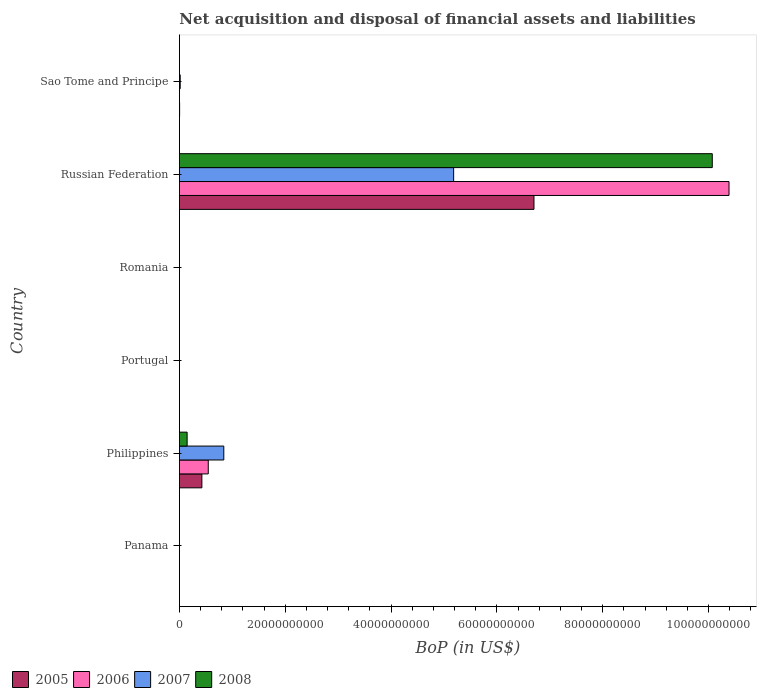How many different coloured bars are there?
Make the answer very short. 4. How many bars are there on the 1st tick from the top?
Keep it short and to the point. 2. How many bars are there on the 3rd tick from the bottom?
Your answer should be compact. 0. What is the label of the 3rd group of bars from the top?
Give a very brief answer. Romania. In how many cases, is the number of bars for a given country not equal to the number of legend labels?
Your answer should be very brief. 4. What is the Balance of Payments in 2006 in Sao Tome and Principe?
Your answer should be very brief. 0. Across all countries, what is the maximum Balance of Payments in 2006?
Offer a very short reply. 1.04e+11. Across all countries, what is the minimum Balance of Payments in 2007?
Give a very brief answer. 0. In which country was the Balance of Payments in 2006 maximum?
Your answer should be compact. Russian Federation. What is the total Balance of Payments in 2007 in the graph?
Make the answer very short. 6.04e+1. What is the difference between the Balance of Payments in 2005 in Philippines and that in Russian Federation?
Your answer should be compact. -6.28e+1. What is the difference between the Balance of Payments in 2007 in Russian Federation and the Balance of Payments in 2008 in Romania?
Your response must be concise. 5.18e+1. What is the average Balance of Payments in 2005 per country?
Ensure brevity in your answer.  1.19e+1. What is the difference between the Balance of Payments in 2008 and Balance of Payments in 2005 in Russian Federation?
Offer a very short reply. 3.37e+1. In how many countries, is the Balance of Payments in 2006 greater than 28000000000 US$?
Provide a succinct answer. 1. What is the difference between the highest and the second highest Balance of Payments in 2005?
Provide a succinct answer. 6.28e+1. What is the difference between the highest and the lowest Balance of Payments in 2007?
Your response must be concise. 5.18e+1. In how many countries, is the Balance of Payments in 2005 greater than the average Balance of Payments in 2005 taken over all countries?
Keep it short and to the point. 1. Is the sum of the Balance of Payments in 2005 in Philippines and Sao Tome and Principe greater than the maximum Balance of Payments in 2006 across all countries?
Ensure brevity in your answer.  No. Is it the case that in every country, the sum of the Balance of Payments in 2007 and Balance of Payments in 2008 is greater than the Balance of Payments in 2006?
Offer a very short reply. No. How many bars are there?
Keep it short and to the point. 10. Are all the bars in the graph horizontal?
Give a very brief answer. Yes. How many countries are there in the graph?
Provide a succinct answer. 6. What is the difference between two consecutive major ticks on the X-axis?
Offer a terse response. 2.00e+1. Does the graph contain any zero values?
Ensure brevity in your answer.  Yes. Where does the legend appear in the graph?
Your answer should be compact. Bottom left. What is the title of the graph?
Provide a succinct answer. Net acquisition and disposal of financial assets and liabilities. What is the label or title of the X-axis?
Ensure brevity in your answer.  BoP (in US$). What is the BoP (in US$) in 2005 in Philippines?
Provide a short and direct response. 4.24e+09. What is the BoP (in US$) of 2006 in Philippines?
Provide a short and direct response. 5.45e+09. What is the BoP (in US$) in 2007 in Philippines?
Provide a short and direct response. 8.39e+09. What is the BoP (in US$) of 2008 in Philippines?
Your response must be concise. 1.46e+09. What is the BoP (in US$) in 2005 in Portugal?
Ensure brevity in your answer.  0. What is the BoP (in US$) of 2007 in Portugal?
Provide a short and direct response. 0. What is the BoP (in US$) in 2006 in Romania?
Provide a succinct answer. 0. What is the BoP (in US$) in 2008 in Romania?
Give a very brief answer. 0. What is the BoP (in US$) of 2005 in Russian Federation?
Your response must be concise. 6.70e+1. What is the BoP (in US$) of 2006 in Russian Federation?
Give a very brief answer. 1.04e+11. What is the BoP (in US$) of 2007 in Russian Federation?
Ensure brevity in your answer.  5.18e+1. What is the BoP (in US$) of 2008 in Russian Federation?
Provide a succinct answer. 1.01e+11. What is the BoP (in US$) in 2005 in Sao Tome and Principe?
Give a very brief answer. 3.62e+07. What is the BoP (in US$) of 2007 in Sao Tome and Principe?
Give a very brief answer. 1.50e+08. What is the BoP (in US$) of 2008 in Sao Tome and Principe?
Your answer should be very brief. 0. Across all countries, what is the maximum BoP (in US$) in 2005?
Give a very brief answer. 6.70e+1. Across all countries, what is the maximum BoP (in US$) of 2006?
Offer a terse response. 1.04e+11. Across all countries, what is the maximum BoP (in US$) of 2007?
Provide a short and direct response. 5.18e+1. Across all countries, what is the maximum BoP (in US$) in 2008?
Offer a very short reply. 1.01e+11. Across all countries, what is the minimum BoP (in US$) in 2005?
Provide a succinct answer. 0. Across all countries, what is the minimum BoP (in US$) of 2008?
Provide a succinct answer. 0. What is the total BoP (in US$) of 2005 in the graph?
Offer a terse response. 7.13e+1. What is the total BoP (in US$) of 2006 in the graph?
Make the answer very short. 1.09e+11. What is the total BoP (in US$) of 2007 in the graph?
Keep it short and to the point. 6.04e+1. What is the total BoP (in US$) in 2008 in the graph?
Your response must be concise. 1.02e+11. What is the difference between the BoP (in US$) in 2005 in Philippines and that in Russian Federation?
Provide a short and direct response. -6.28e+1. What is the difference between the BoP (in US$) of 2006 in Philippines and that in Russian Federation?
Ensure brevity in your answer.  -9.84e+1. What is the difference between the BoP (in US$) in 2007 in Philippines and that in Russian Federation?
Give a very brief answer. -4.34e+1. What is the difference between the BoP (in US$) of 2008 in Philippines and that in Russian Federation?
Give a very brief answer. -9.92e+1. What is the difference between the BoP (in US$) of 2005 in Philippines and that in Sao Tome and Principe?
Provide a succinct answer. 4.21e+09. What is the difference between the BoP (in US$) in 2007 in Philippines and that in Sao Tome and Principe?
Your answer should be compact. 8.24e+09. What is the difference between the BoP (in US$) of 2005 in Russian Federation and that in Sao Tome and Principe?
Keep it short and to the point. 6.70e+1. What is the difference between the BoP (in US$) in 2007 in Russian Federation and that in Sao Tome and Principe?
Provide a succinct answer. 5.17e+1. What is the difference between the BoP (in US$) in 2005 in Philippines and the BoP (in US$) in 2006 in Russian Federation?
Make the answer very short. -9.96e+1. What is the difference between the BoP (in US$) of 2005 in Philippines and the BoP (in US$) of 2007 in Russian Federation?
Make the answer very short. -4.76e+1. What is the difference between the BoP (in US$) of 2005 in Philippines and the BoP (in US$) of 2008 in Russian Federation?
Keep it short and to the point. -9.64e+1. What is the difference between the BoP (in US$) of 2006 in Philippines and the BoP (in US$) of 2007 in Russian Federation?
Provide a short and direct response. -4.64e+1. What is the difference between the BoP (in US$) in 2006 in Philippines and the BoP (in US$) in 2008 in Russian Federation?
Your response must be concise. -9.52e+1. What is the difference between the BoP (in US$) of 2007 in Philippines and the BoP (in US$) of 2008 in Russian Federation?
Keep it short and to the point. -9.23e+1. What is the difference between the BoP (in US$) in 2005 in Philippines and the BoP (in US$) in 2007 in Sao Tome and Principe?
Offer a very short reply. 4.09e+09. What is the difference between the BoP (in US$) of 2006 in Philippines and the BoP (in US$) of 2007 in Sao Tome and Principe?
Your answer should be very brief. 5.30e+09. What is the difference between the BoP (in US$) of 2005 in Russian Federation and the BoP (in US$) of 2007 in Sao Tome and Principe?
Offer a very short reply. 6.68e+1. What is the difference between the BoP (in US$) of 2006 in Russian Federation and the BoP (in US$) of 2007 in Sao Tome and Principe?
Provide a short and direct response. 1.04e+11. What is the average BoP (in US$) in 2005 per country?
Make the answer very short. 1.19e+1. What is the average BoP (in US$) in 2006 per country?
Give a very brief answer. 1.82e+1. What is the average BoP (in US$) of 2007 per country?
Provide a short and direct response. 1.01e+1. What is the average BoP (in US$) in 2008 per country?
Offer a very short reply. 1.70e+1. What is the difference between the BoP (in US$) of 2005 and BoP (in US$) of 2006 in Philippines?
Your answer should be compact. -1.21e+09. What is the difference between the BoP (in US$) in 2005 and BoP (in US$) in 2007 in Philippines?
Offer a very short reply. -4.14e+09. What is the difference between the BoP (in US$) of 2005 and BoP (in US$) of 2008 in Philippines?
Your answer should be very brief. 2.79e+09. What is the difference between the BoP (in US$) of 2006 and BoP (in US$) of 2007 in Philippines?
Keep it short and to the point. -2.93e+09. What is the difference between the BoP (in US$) of 2006 and BoP (in US$) of 2008 in Philippines?
Offer a terse response. 3.99e+09. What is the difference between the BoP (in US$) of 2007 and BoP (in US$) of 2008 in Philippines?
Your response must be concise. 6.93e+09. What is the difference between the BoP (in US$) in 2005 and BoP (in US$) in 2006 in Russian Federation?
Give a very brief answer. -3.69e+1. What is the difference between the BoP (in US$) in 2005 and BoP (in US$) in 2007 in Russian Federation?
Give a very brief answer. 1.52e+1. What is the difference between the BoP (in US$) of 2005 and BoP (in US$) of 2008 in Russian Federation?
Provide a short and direct response. -3.37e+1. What is the difference between the BoP (in US$) of 2006 and BoP (in US$) of 2007 in Russian Federation?
Provide a succinct answer. 5.20e+1. What is the difference between the BoP (in US$) in 2006 and BoP (in US$) in 2008 in Russian Federation?
Ensure brevity in your answer.  3.16e+09. What is the difference between the BoP (in US$) in 2007 and BoP (in US$) in 2008 in Russian Federation?
Your response must be concise. -4.89e+1. What is the difference between the BoP (in US$) in 2005 and BoP (in US$) in 2007 in Sao Tome and Principe?
Offer a terse response. -1.14e+08. What is the ratio of the BoP (in US$) in 2005 in Philippines to that in Russian Federation?
Give a very brief answer. 0.06. What is the ratio of the BoP (in US$) in 2006 in Philippines to that in Russian Federation?
Your answer should be very brief. 0.05. What is the ratio of the BoP (in US$) of 2007 in Philippines to that in Russian Federation?
Ensure brevity in your answer.  0.16. What is the ratio of the BoP (in US$) in 2008 in Philippines to that in Russian Federation?
Your answer should be very brief. 0.01. What is the ratio of the BoP (in US$) in 2005 in Philippines to that in Sao Tome and Principe?
Give a very brief answer. 117.32. What is the ratio of the BoP (in US$) in 2007 in Philippines to that in Sao Tome and Principe?
Provide a short and direct response. 55.73. What is the ratio of the BoP (in US$) of 2005 in Russian Federation to that in Sao Tome and Principe?
Keep it short and to the point. 1852.28. What is the ratio of the BoP (in US$) in 2007 in Russian Federation to that in Sao Tome and Principe?
Make the answer very short. 344.37. What is the difference between the highest and the second highest BoP (in US$) of 2005?
Offer a terse response. 6.28e+1. What is the difference between the highest and the second highest BoP (in US$) of 2007?
Give a very brief answer. 4.34e+1. What is the difference between the highest and the lowest BoP (in US$) in 2005?
Your response must be concise. 6.70e+1. What is the difference between the highest and the lowest BoP (in US$) of 2006?
Offer a very short reply. 1.04e+11. What is the difference between the highest and the lowest BoP (in US$) in 2007?
Ensure brevity in your answer.  5.18e+1. What is the difference between the highest and the lowest BoP (in US$) of 2008?
Provide a short and direct response. 1.01e+11. 